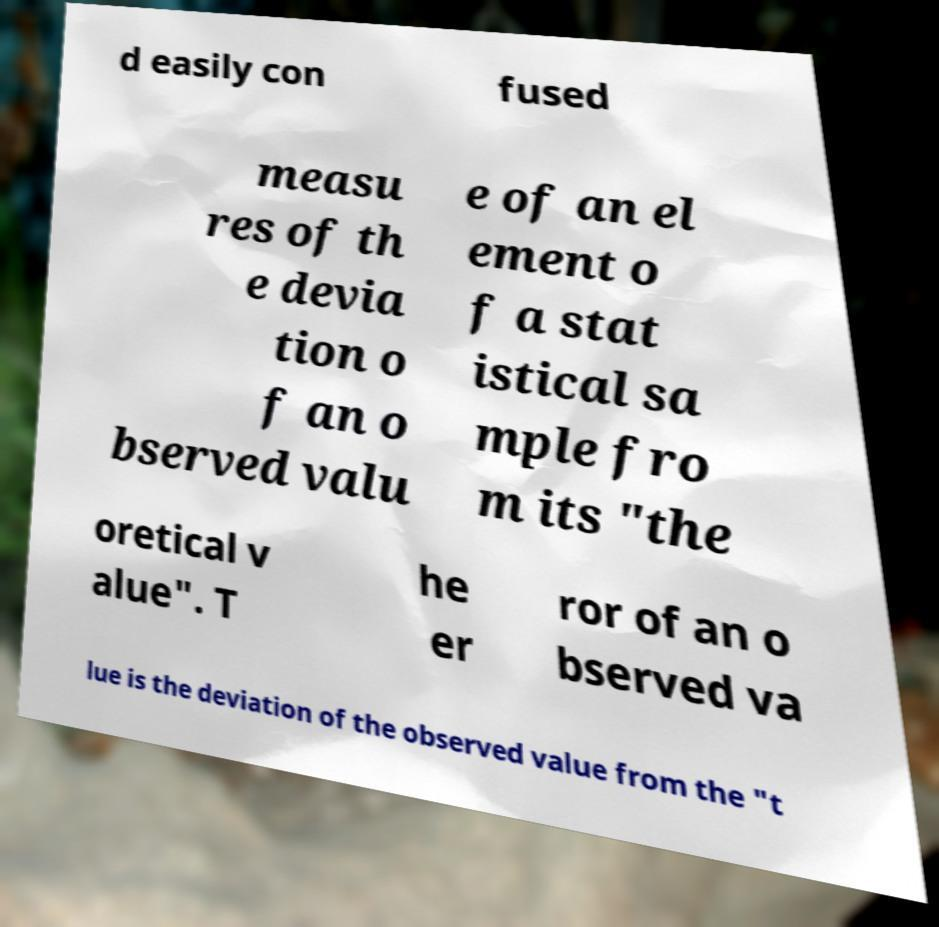Please identify and transcribe the text found in this image. d easily con fused measu res of th e devia tion o f an o bserved valu e of an el ement o f a stat istical sa mple fro m its "the oretical v alue". T he er ror of an o bserved va lue is the deviation of the observed value from the "t 